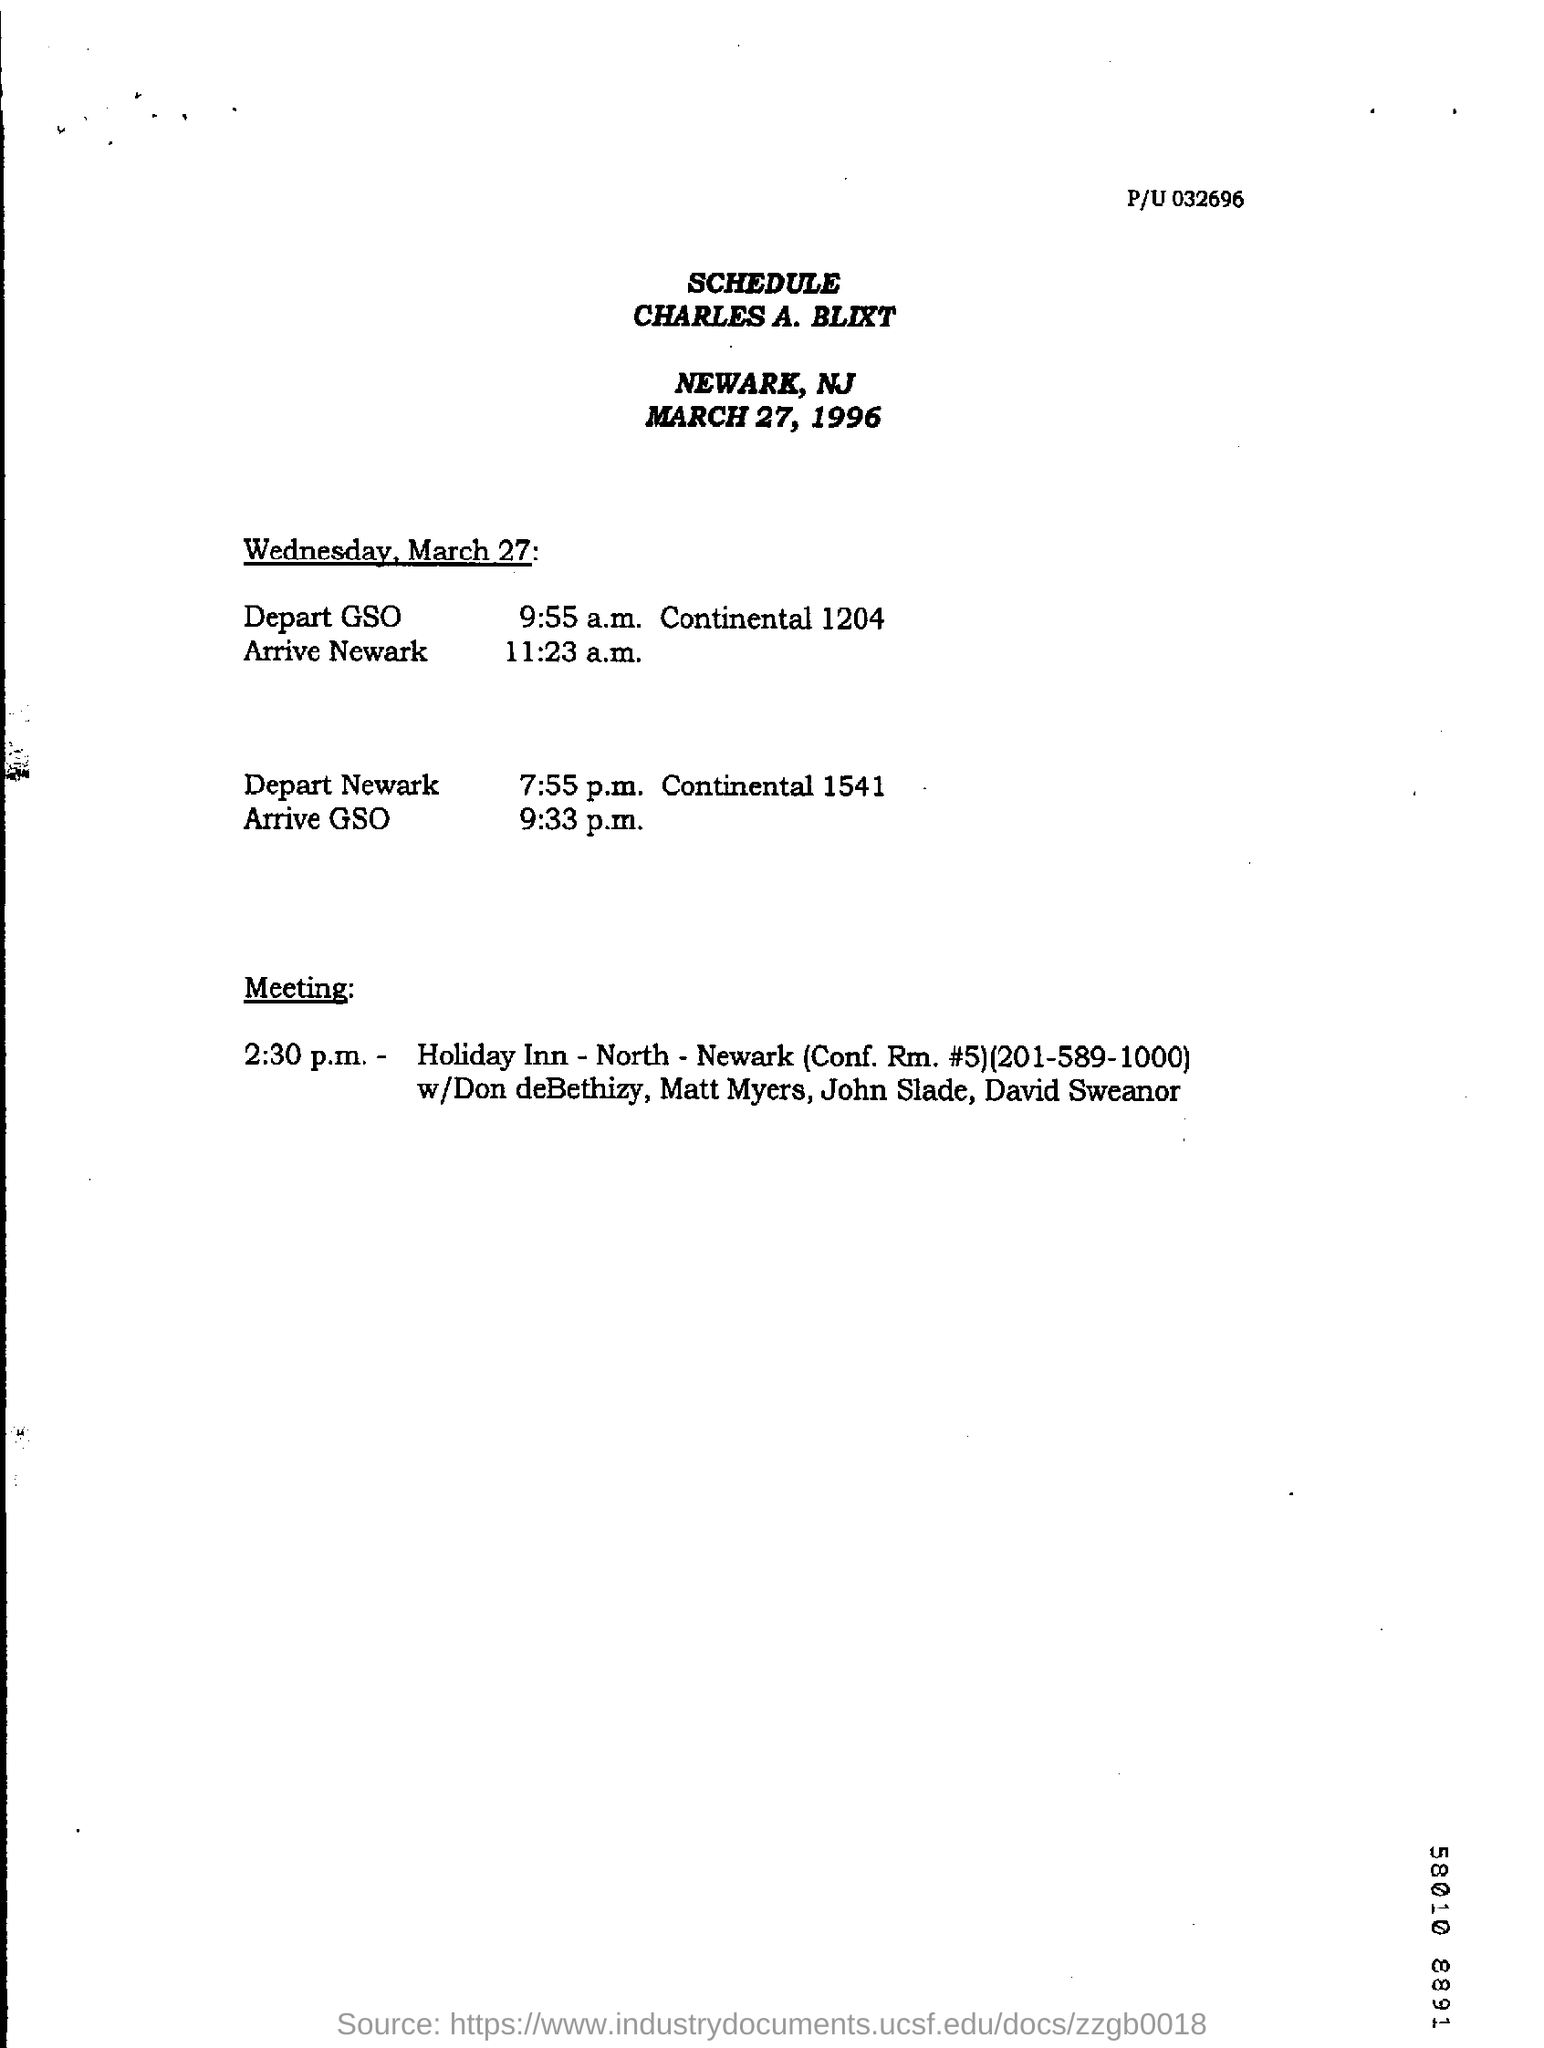What is the depart time of GSO?
Make the answer very short. 9:55 a.m. Continental 1204. What is the arrival time in GSO?
Provide a succinct answer. 9:33 p.m. 